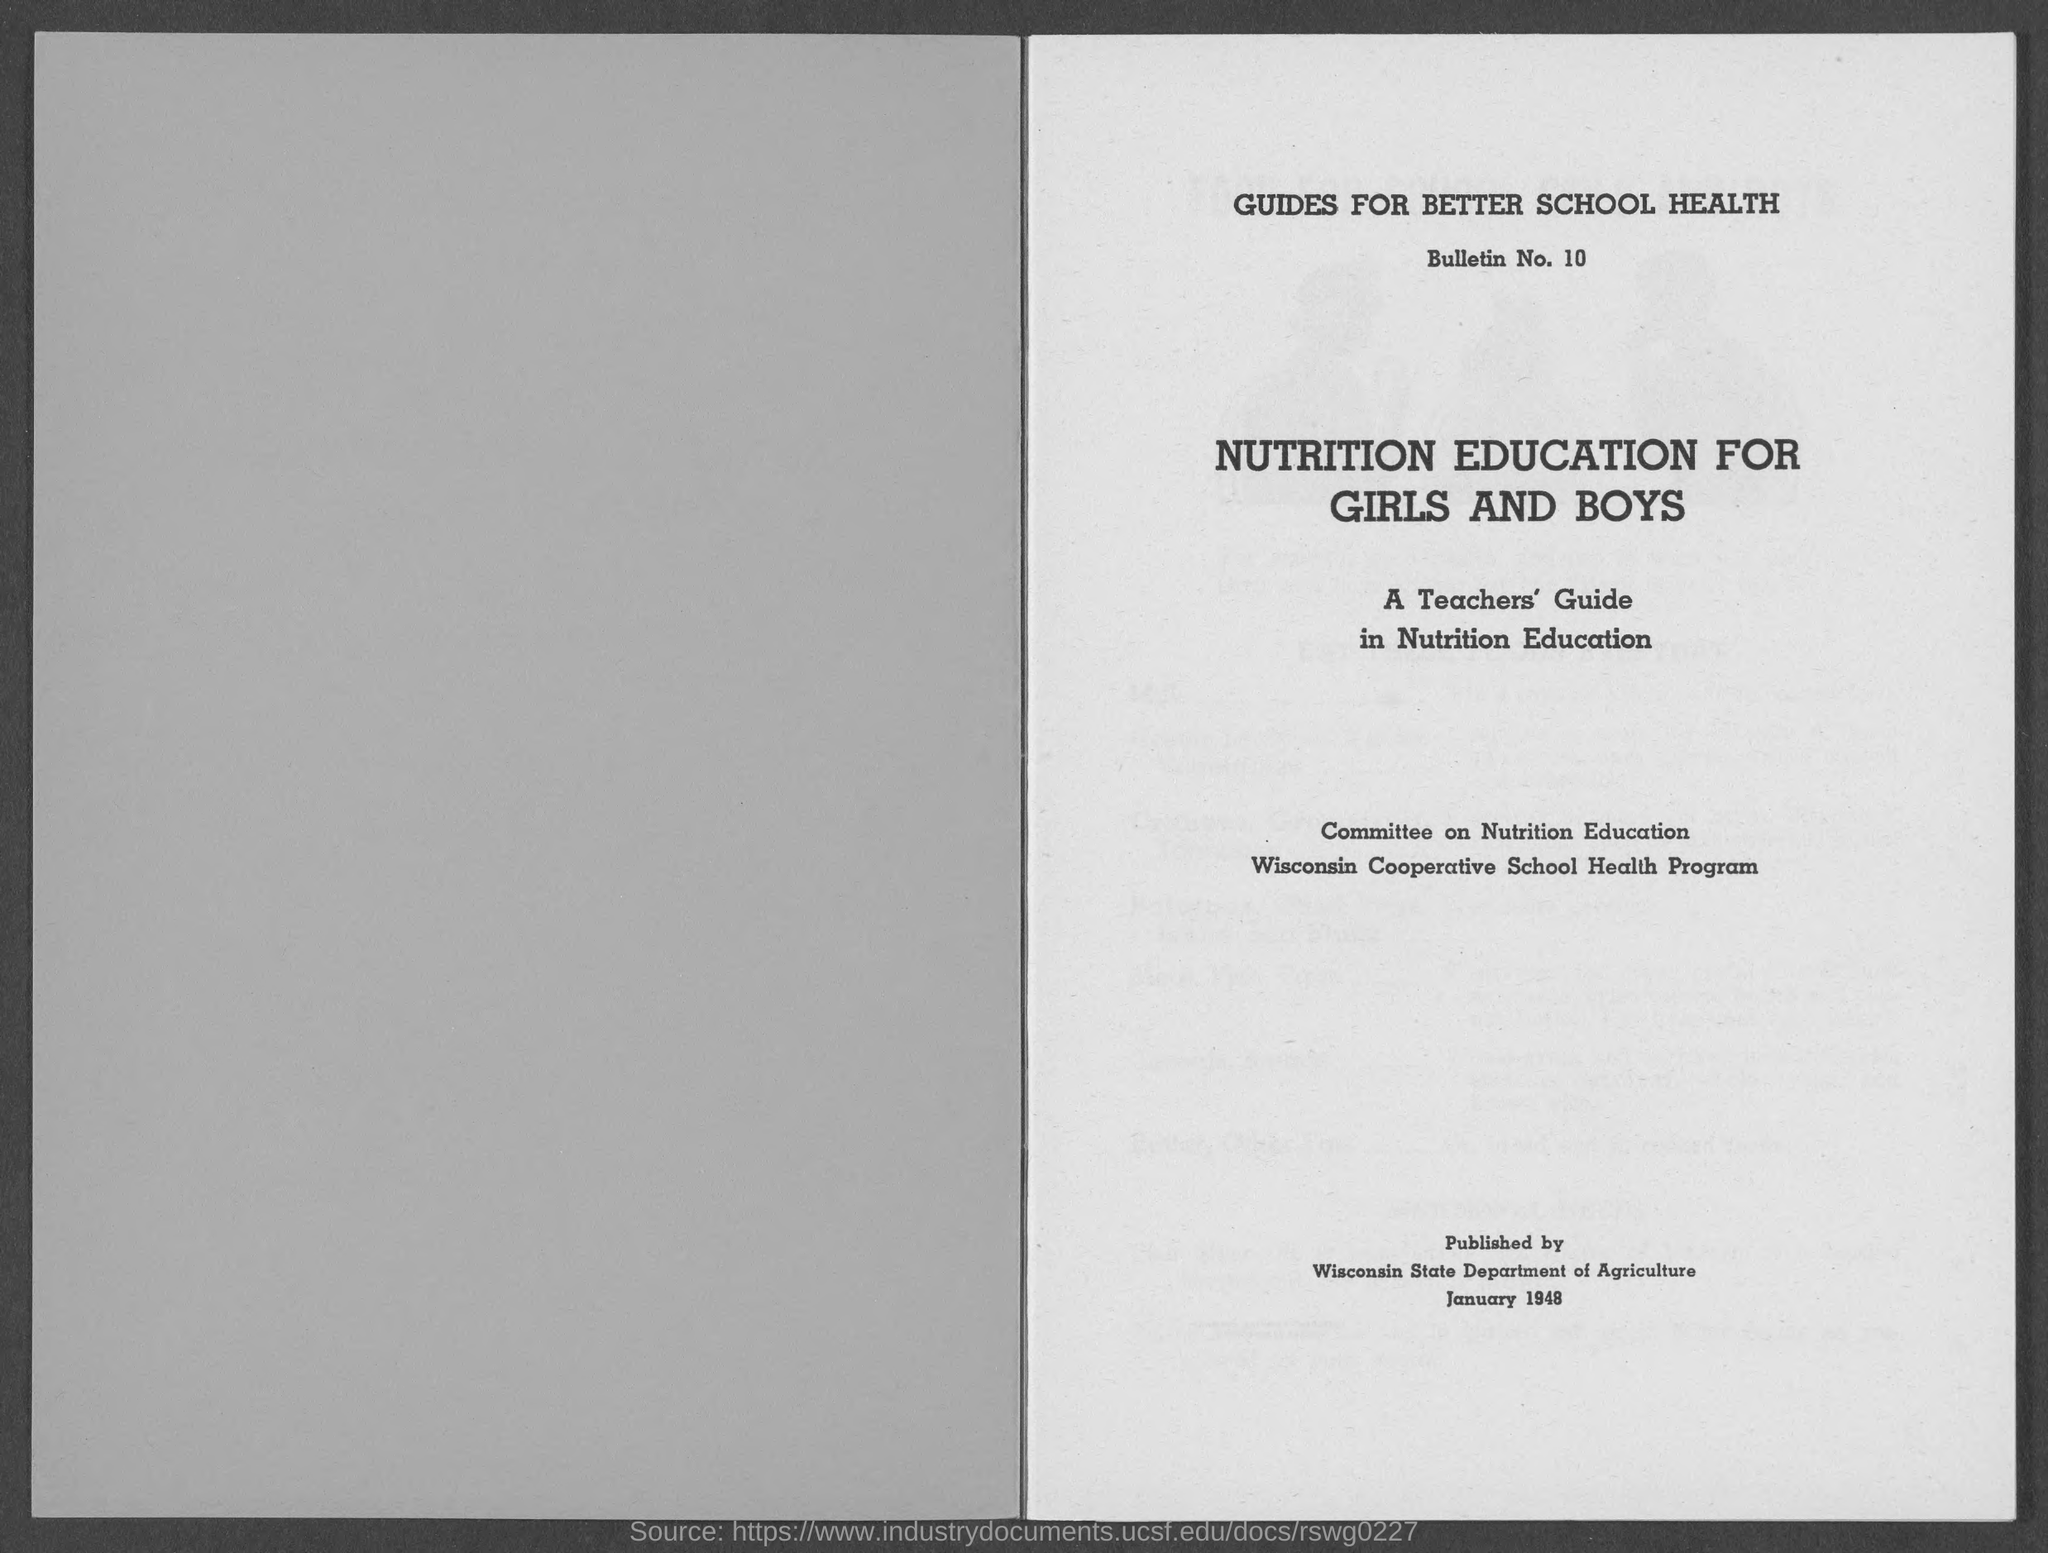What is the bulletin no ?
Your answer should be compact. 10. This is published by whom ?
Offer a very short reply. Wisconsin state Department of Agriculture. What is the date of published ?
Offer a very short reply. JANUARY 1948. 